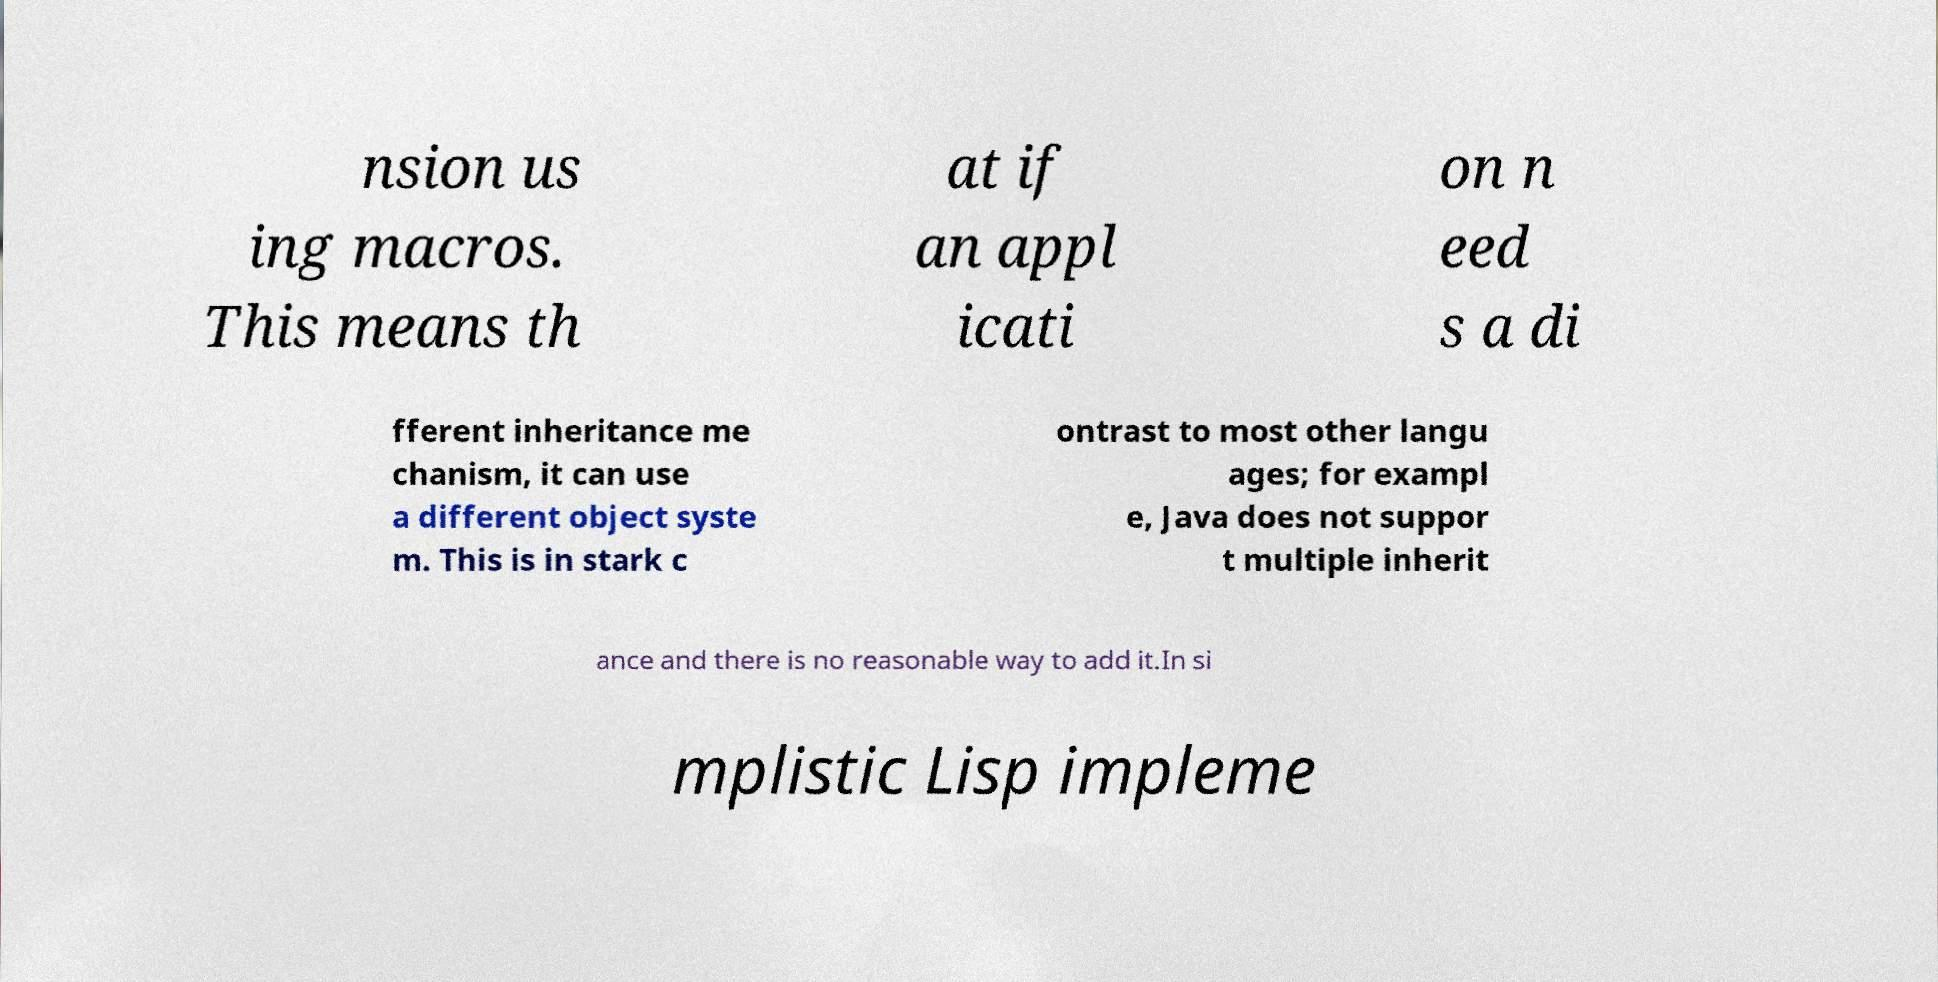What messages or text are displayed in this image? I need them in a readable, typed format. nsion us ing macros. This means th at if an appl icati on n eed s a di fferent inheritance me chanism, it can use a different object syste m. This is in stark c ontrast to most other langu ages; for exampl e, Java does not suppor t multiple inherit ance and there is no reasonable way to add it.In si mplistic Lisp impleme 